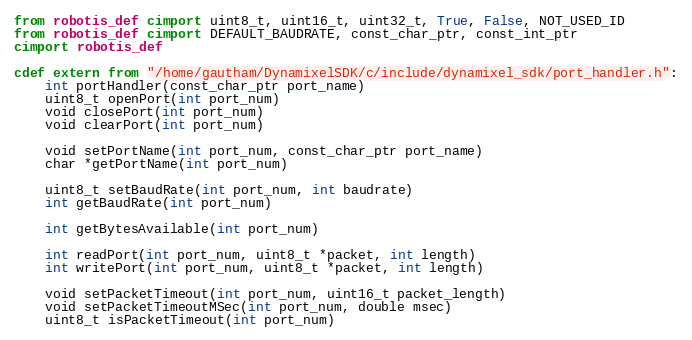<code> <loc_0><loc_0><loc_500><loc_500><_Cython_>from robotis_def cimport uint8_t, uint16_t, uint32_t, True, False, NOT_USED_ID
from robotis_def cimport DEFAULT_BAUDRATE, const_char_ptr, const_int_ptr
cimport robotis_def

cdef extern from "/home/gautham/DynamixelSDK/c/include/dynamixel_sdk/port_handler.h":
    int portHandler(const_char_ptr port_name)
    uint8_t openPort(int port_num)
    void closePort(int port_num)
    void clearPort(int port_num)

    void setPortName(int port_num, const_char_ptr port_name)
    char *getPortName(int port_num)

    uint8_t setBaudRate(int port_num, int baudrate)
    int getBaudRate(int port_num)

    int getBytesAvailable(int port_num)

    int readPort(int port_num, uint8_t *packet, int length)
    int writePort(int port_num, uint8_t *packet, int length)

    void setPacketTimeout(int port_num, uint16_t packet_length)
    void setPacketTimeoutMSec(int port_num, double msec)
    uint8_t isPacketTimeout(int port_num)</code> 